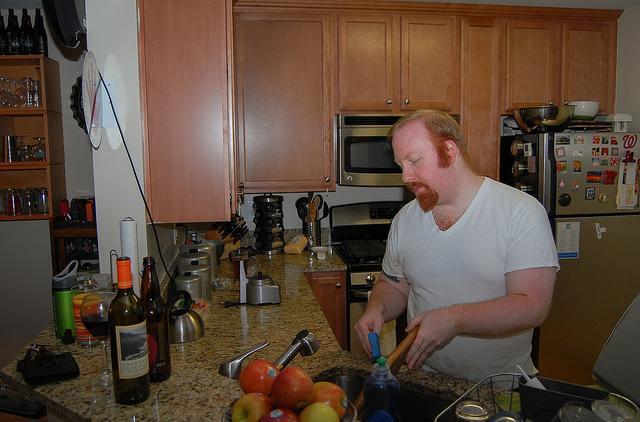How many wine glasses are there?
Give a very brief answer. 1. How many mirrors are in the photo?
Give a very brief answer. 0. How many people are in the photo?
Give a very brief answer. 1. How many wine bottles are on the table?
Give a very brief answer. 2. How many sinks are in this photo?
Give a very brief answer. 1. How many different types of fruit are shown?
Give a very brief answer. 1. How many bottles are on the table?
Give a very brief answer. 2. How many bottles of wine are in the picture?
Give a very brief answer. 1. How many people are in this image?
Give a very brief answer. 1. How many stoves are there?
Give a very brief answer. 1. How many refrigerators can be seen?
Give a very brief answer. 1. How many bowls are there?
Give a very brief answer. 1. How many sinks are in the photo?
Give a very brief answer. 1. How many bottles are in the photo?
Give a very brief answer. 2. 